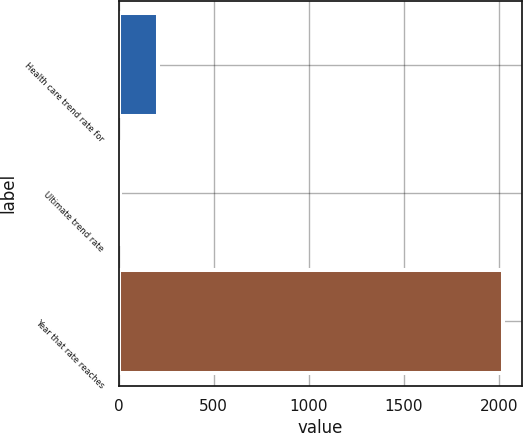Convert chart to OTSL. <chart><loc_0><loc_0><loc_500><loc_500><bar_chart><fcel>Health care trend rate for<fcel>Ultimate trend rate<fcel>Year that rate reaches<nl><fcel>206.6<fcel>5<fcel>2021<nl></chart> 